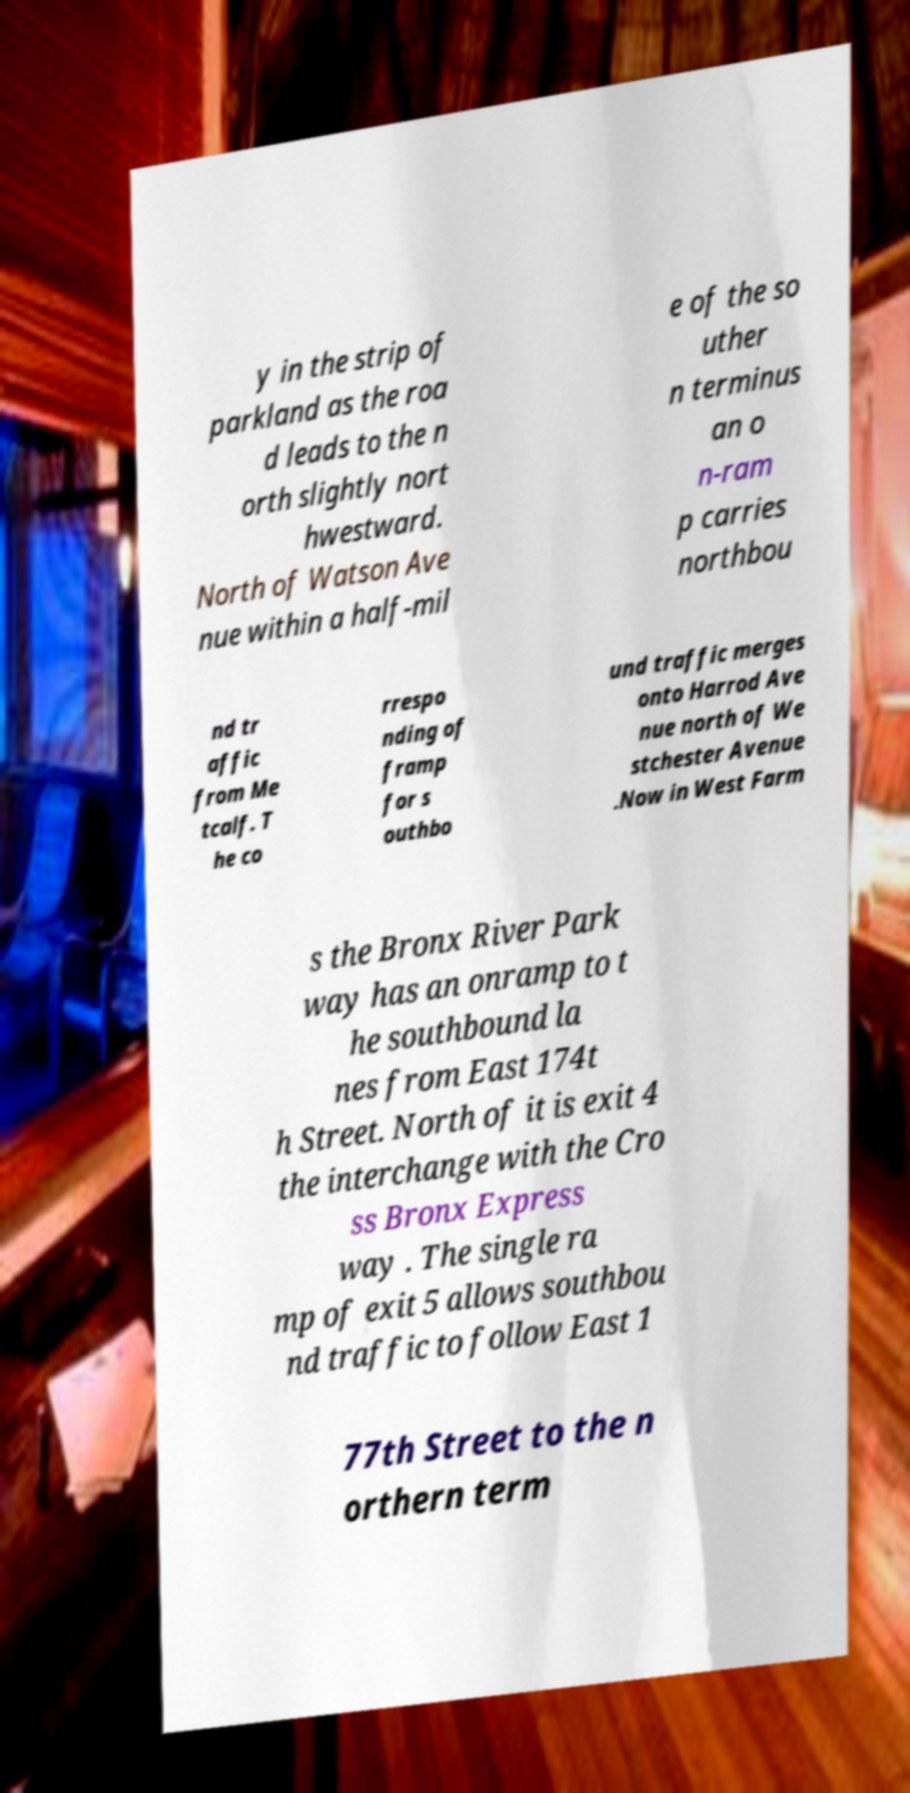For documentation purposes, I need the text within this image transcribed. Could you provide that? y in the strip of parkland as the roa d leads to the n orth slightly nort hwestward. North of Watson Ave nue within a half-mil e of the so uther n terminus an o n-ram p carries northbou nd tr affic from Me tcalf. T he co rrespo nding of framp for s outhbo und traffic merges onto Harrod Ave nue north of We stchester Avenue .Now in West Farm s the Bronx River Park way has an onramp to t he southbound la nes from East 174t h Street. North of it is exit 4 the interchange with the Cro ss Bronx Express way . The single ra mp of exit 5 allows southbou nd traffic to follow East 1 77th Street to the n orthern term 